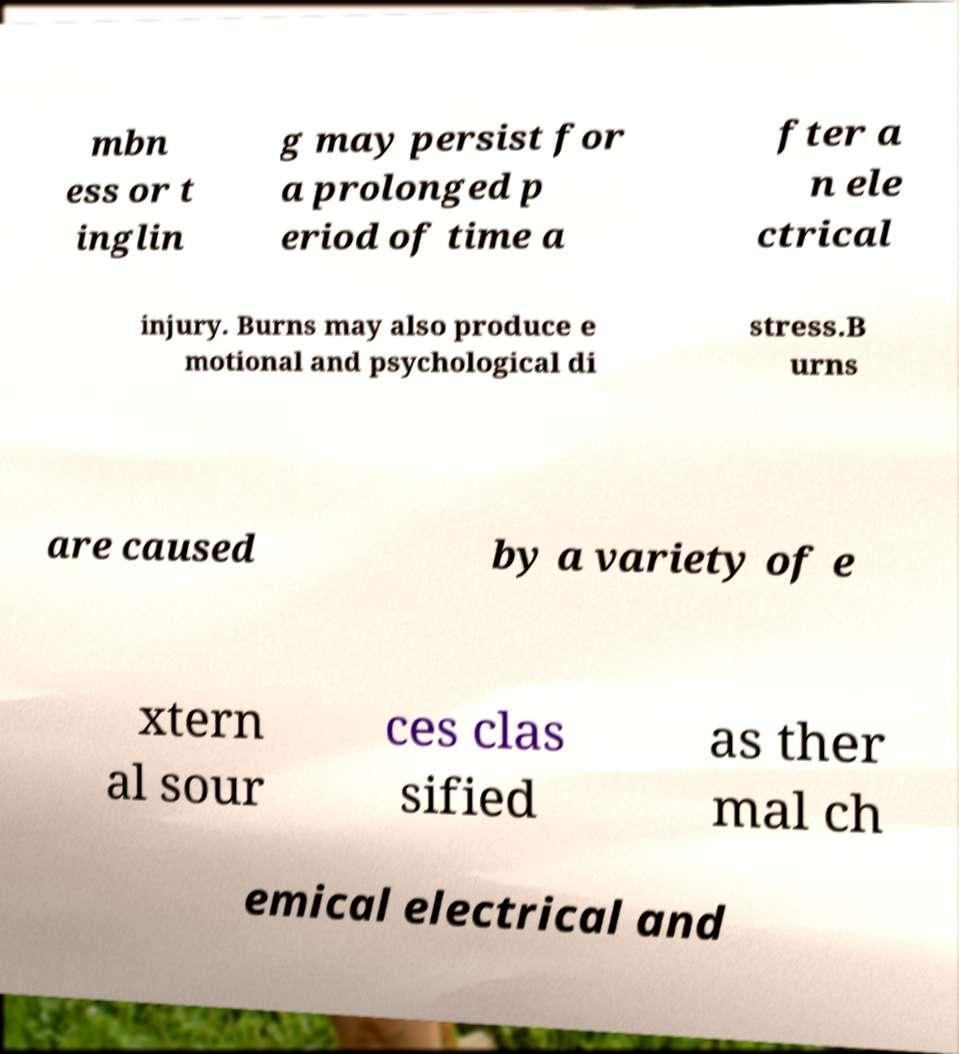Could you assist in decoding the text presented in this image and type it out clearly? mbn ess or t inglin g may persist for a prolonged p eriod of time a fter a n ele ctrical injury. Burns may also produce e motional and psychological di stress.B urns are caused by a variety of e xtern al sour ces clas sified as ther mal ch emical electrical and 